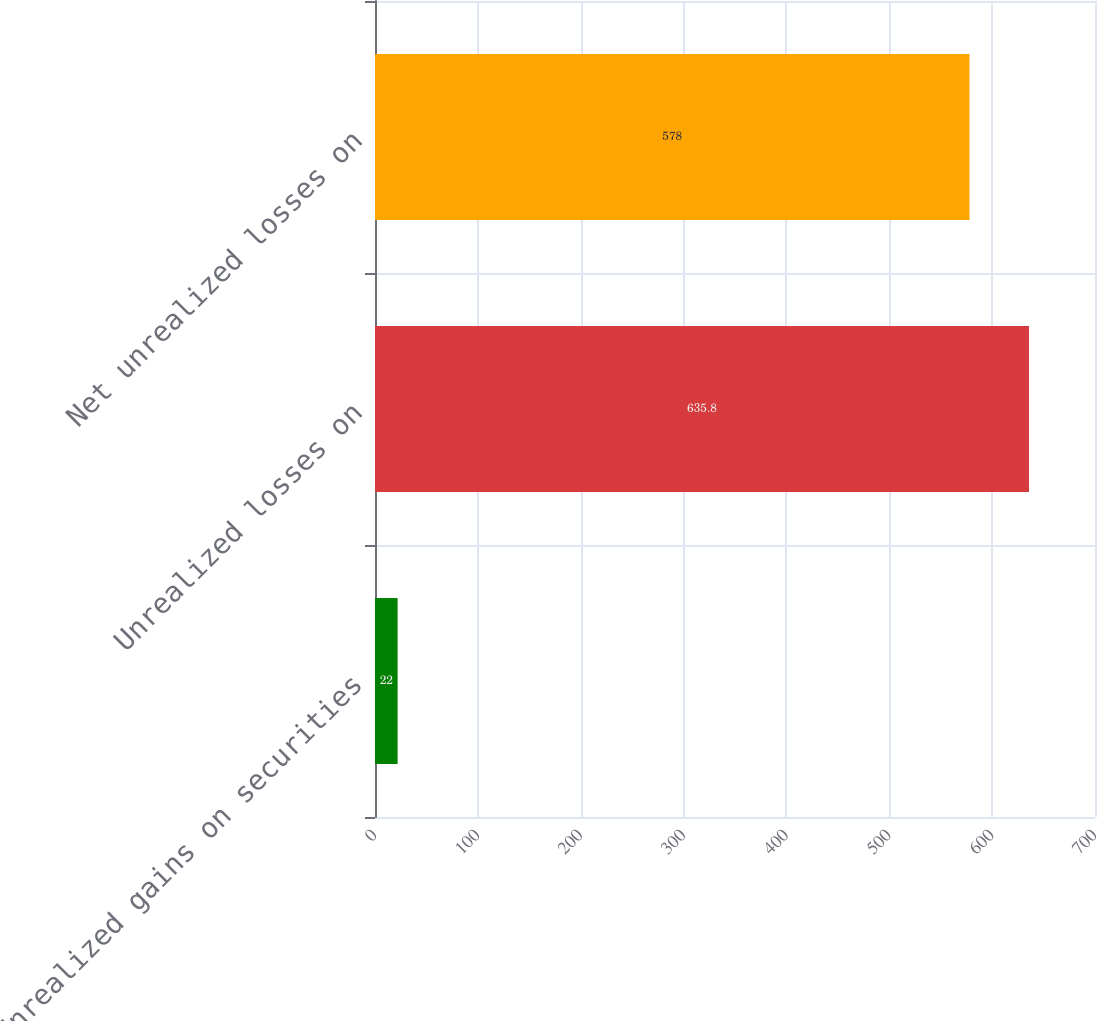Convert chart to OTSL. <chart><loc_0><loc_0><loc_500><loc_500><bar_chart><fcel>Unrealized gains on securities<fcel>Unrealized losses on<fcel>Net unrealized losses on<nl><fcel>22<fcel>635.8<fcel>578<nl></chart> 